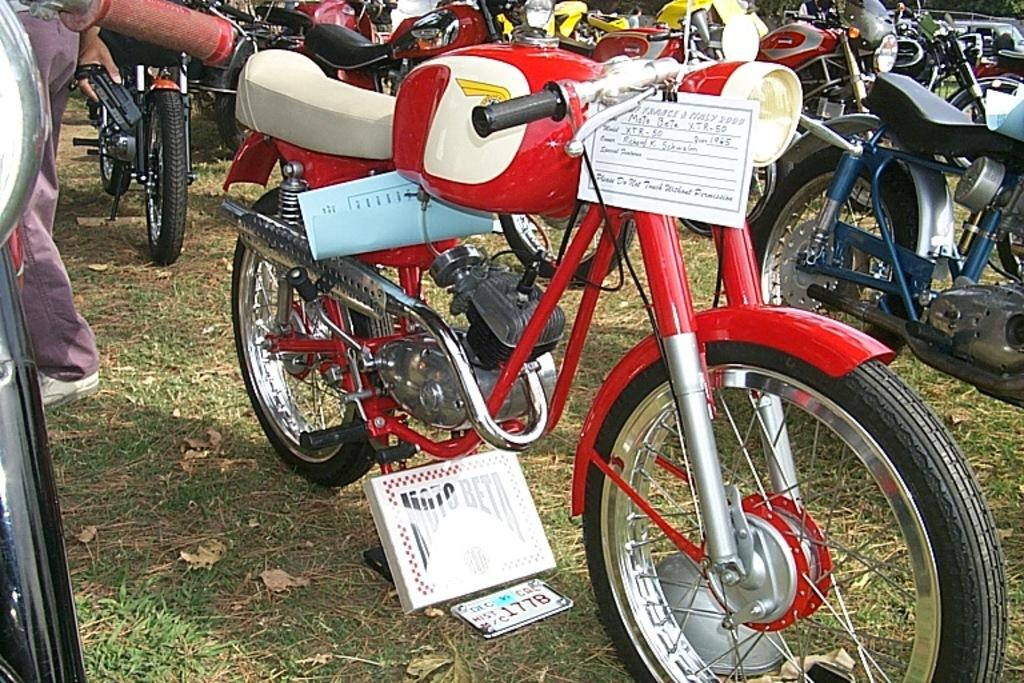What is located on the grass in the image? There are vehicles on the grass in the image. What else can be seen in the image besides the vehicles? There are papers visible in the image. Where is the person in the image positioned? The person is on the left side of the image. What is the person holding in the image? The person is holding a device. How does the person increase their income in the image? There is no information about income in the image; it only shows a person holding a device and vehicles on the grass. What type of action is the person performing with the device in the image? The image does not show any specific action being performed with the device; it only shows the person holding it. 